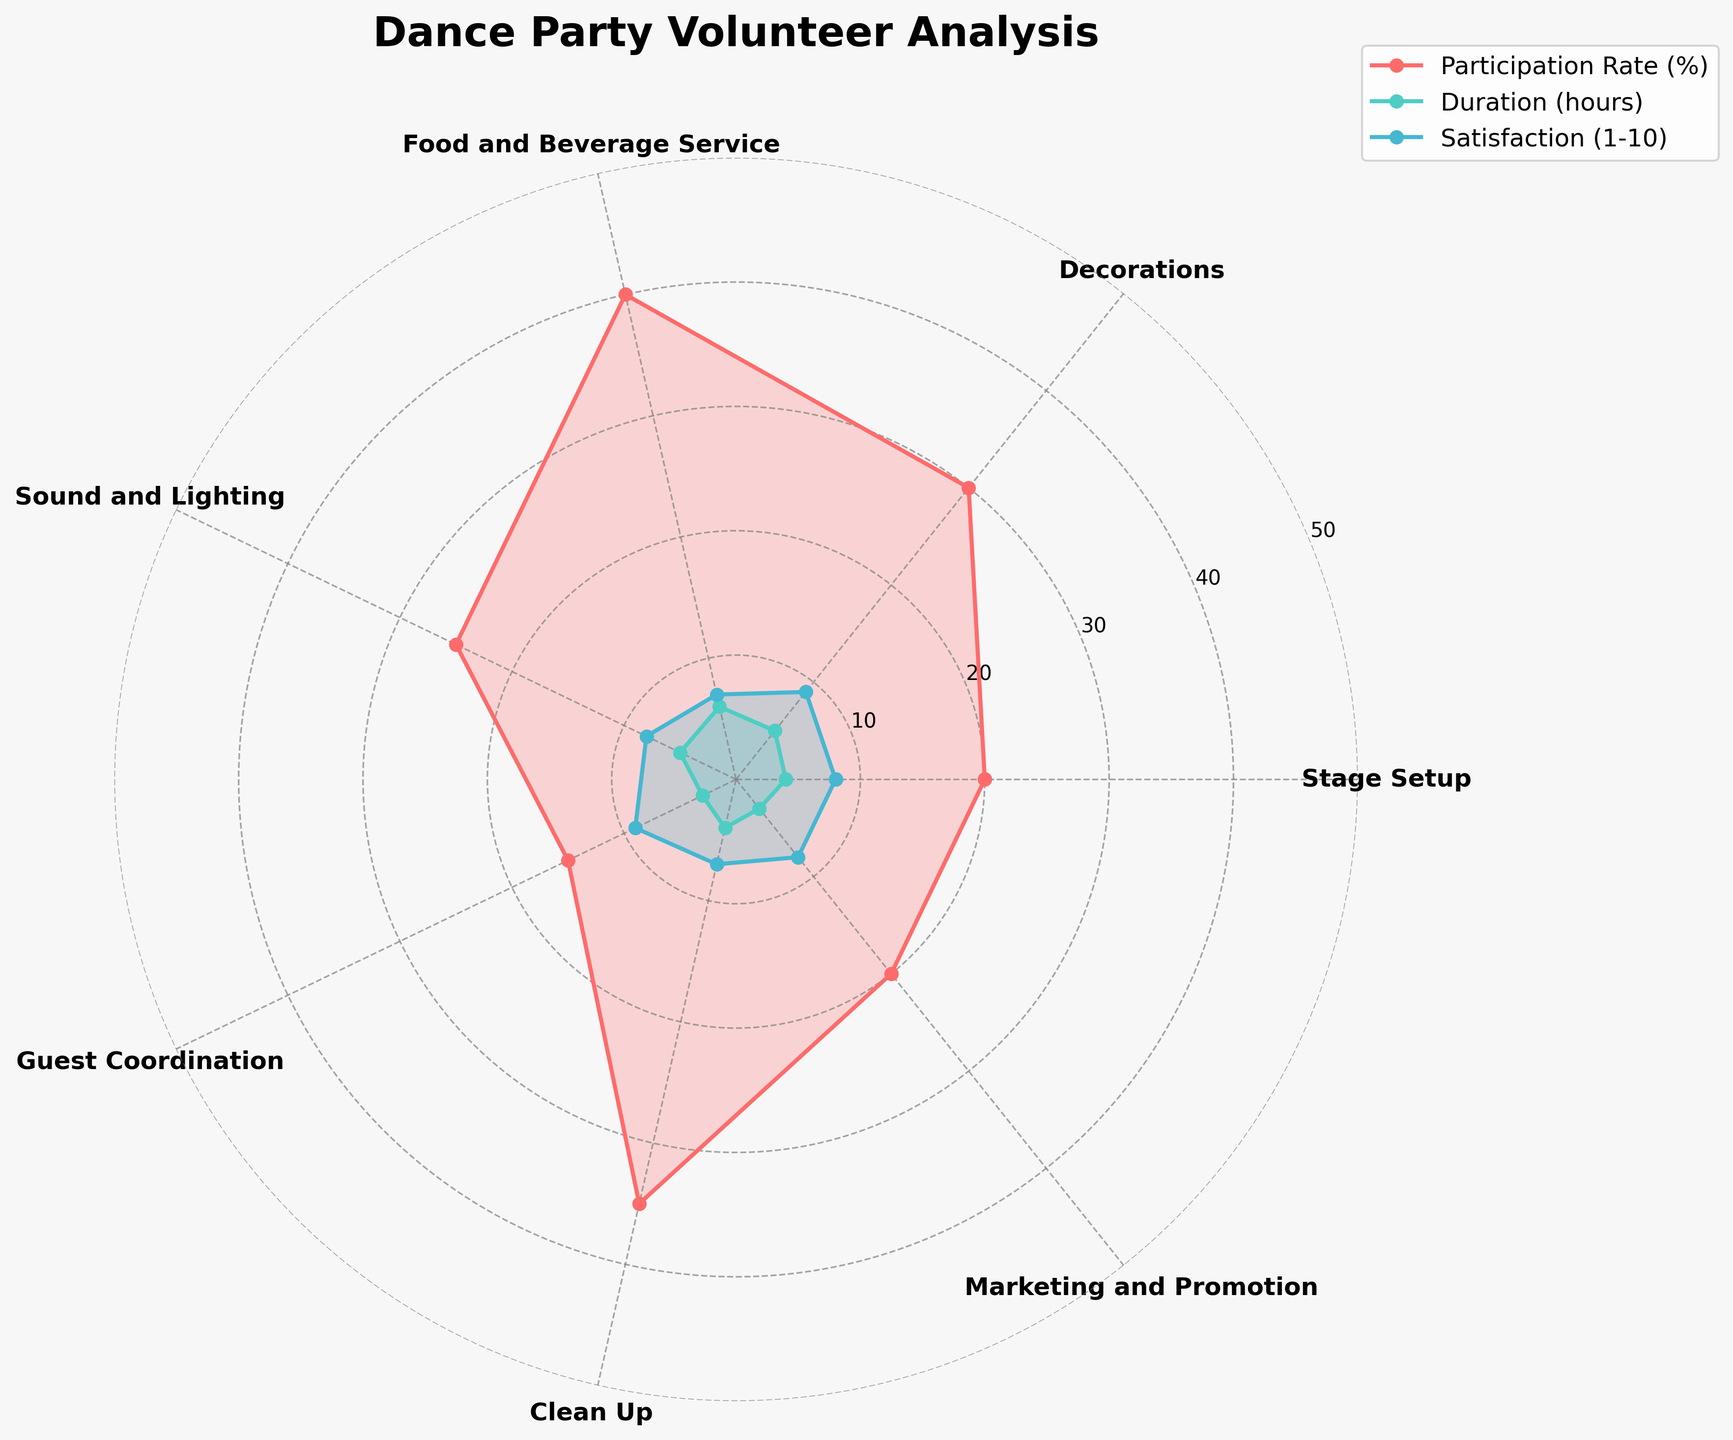What is the title of the figure? The title is usually located at the top center of the chart. In this figure, it reads "Dance Party Volunteer Analysis".
Answer: Dance Party Volunteer Analysis How many categories are analyzed in the figure? The categories can be counted based on their labels around the polar plot. There are 7 categories listed which are: Stage Setup, Decorations, Food and Beverage Service, Sound and Lighting, Guest Coordination, Clean Up, and Marketing and Promotion.
Answer: 7 Which category has the highest Volunteer Participation Rate? By examining the plot where each category is represented around the polar chart, the "Food and Beverage Service" category reaches the furthest outward, indicating the highest participation rate.
Answer: Food and Beverage Service Among the categories, which one has the lowest Average Duration of Volunteership? Looking at the inner part of the polar chart, "Guest Coordination" is closest to the center for the duration plot line, showing it has the lowest duration.
Answer: Guest Coordination Which two categories have the same Experience Satisfaction Score? By comparing the Satisfaction Score plot lines, "Stage Setup" and "Sound and Lighting" both reach the same value, which confirms they share a satisfaction score.
Answer: Stage Setup and Sound and Lighting What is the difference in Volunteer Participation Rate between Decorations and Clean Up? From the plot, "Decorations" has 30% participation and "Clean Up" has 35%. The difference can be calculated as 35 - 30 = 5%.
Answer: 5% Which category has the highest Experience Satisfaction Score and what percentage is the Volunteer Participation Rate for this category? The highest Experience Satisfaction Score reaches the furthest outward in the plot for "Decorations" and "Guest Coordination" both marked at 9. The Volunteer Participation Rates are 30% and 15% respectively. 30% belongs to "Decorations".
Answer: Decorations, 30% What is the average Experience Satisfaction Score across all categories? To find the average satisfaction score, sum all the scores (8 + 9 + 7 + 8 + 9 + 7 + 8 = 56) and divide by the number of categories (7). Thus, the average satisfaction score is 56/7.
Answer: 8 Between "Stage Setup" and "Marketing and Promotion", which category has a higher Average Duration of Volunteership? By observing the duration plot line, "Stage Setup" and "Marketing and Promotion" are both plotted but "Stage Setup" extends further outwards at 4 hours compared to 3 hours for "Marketing and Promotion".
Answer: Stage Setup 